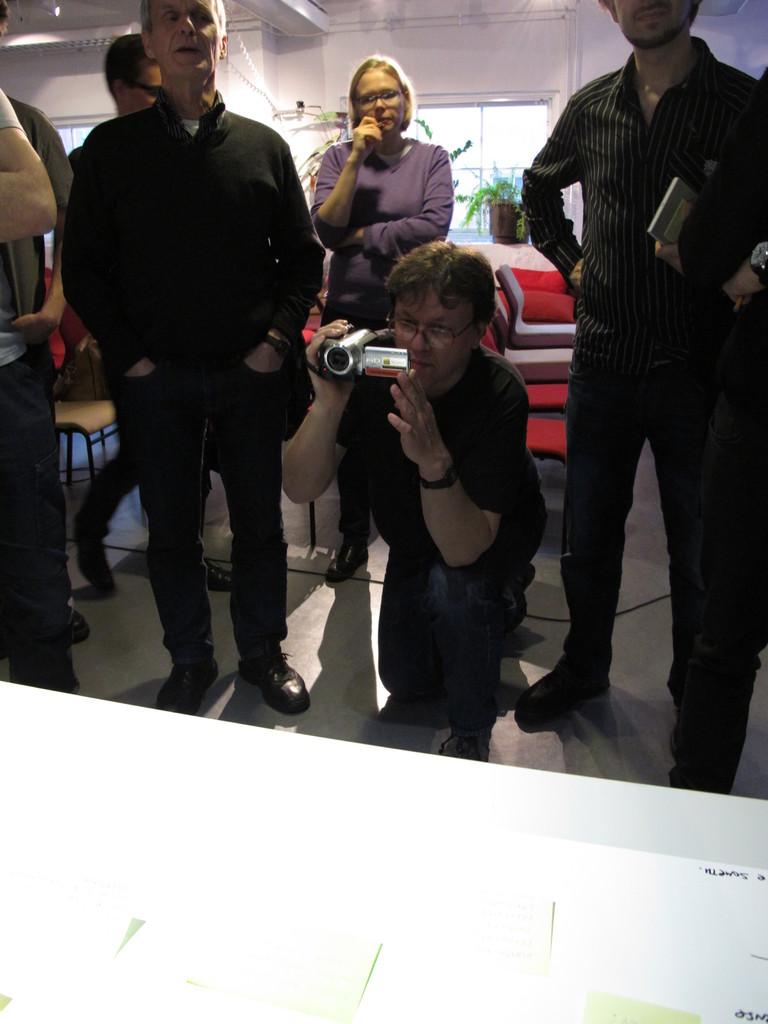How many people are in the image? There are people in the image, but the exact number is not specified. What is one person doing in the image? One person is holding a camera in the image. What can be seen through the windows in the image? The presence of windows in the image suggests that there might be a view or scenery visible, but the specifics are not mentioned. What is located near the windows in the image? There is a flowerpot in the image. What type of structure is visible in the image? There is a wall in the image. What type of plastic bag is being used to carry the flowers in the image? There is no plastic bag or flowers present in the image. What type of flooring can be seen in the image? The facts provided do not mention any flooring in the image. 